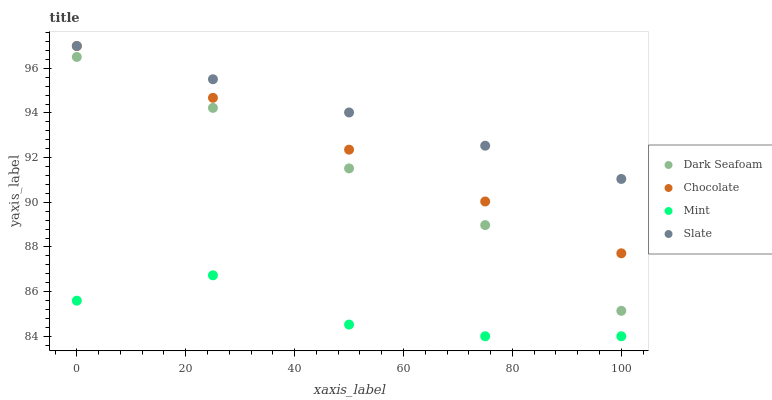Does Mint have the minimum area under the curve?
Answer yes or no. Yes. Does Slate have the maximum area under the curve?
Answer yes or no. Yes. Does Slate have the minimum area under the curve?
Answer yes or no. No. Does Mint have the maximum area under the curve?
Answer yes or no. No. Is Chocolate the smoothest?
Answer yes or no. Yes. Is Mint the roughest?
Answer yes or no. Yes. Is Slate the smoothest?
Answer yes or no. No. Is Slate the roughest?
Answer yes or no. No. Does Mint have the lowest value?
Answer yes or no. Yes. Does Slate have the lowest value?
Answer yes or no. No. Does Chocolate have the highest value?
Answer yes or no. Yes. Does Mint have the highest value?
Answer yes or no. No. Is Mint less than Slate?
Answer yes or no. Yes. Is Slate greater than Dark Seafoam?
Answer yes or no. Yes. Does Slate intersect Chocolate?
Answer yes or no. Yes. Is Slate less than Chocolate?
Answer yes or no. No. Is Slate greater than Chocolate?
Answer yes or no. No. Does Mint intersect Slate?
Answer yes or no. No. 